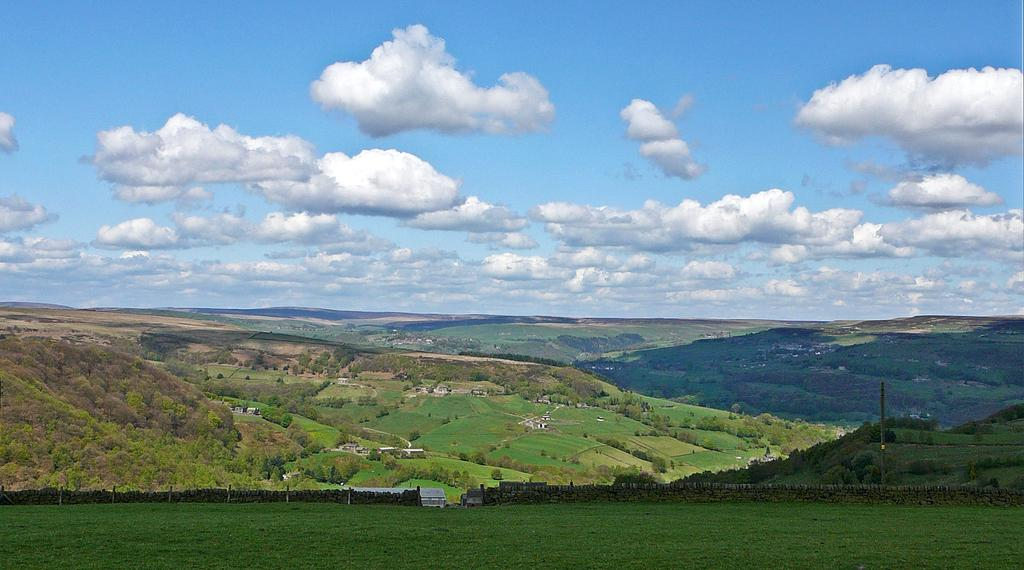What can be seen in the sky in the image? The sky with clouds is visible in the image. What type of natural features are present in the image? There are hills and trees visible in the image. What type of man-made structures can be seen in the image? Buildings are visible in the image. What is the surface on which the other elements are situated? The ground is visible in the image. What type of reward is being given to the idea in the image? There is no reward or idea present in the image; it features natural and man-made elements such as the sky, clouds, hills, trees, buildings, and ground. 